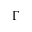Convert formula to latex. <formula><loc_0><loc_0><loc_500><loc_500>\Gamma</formula> 